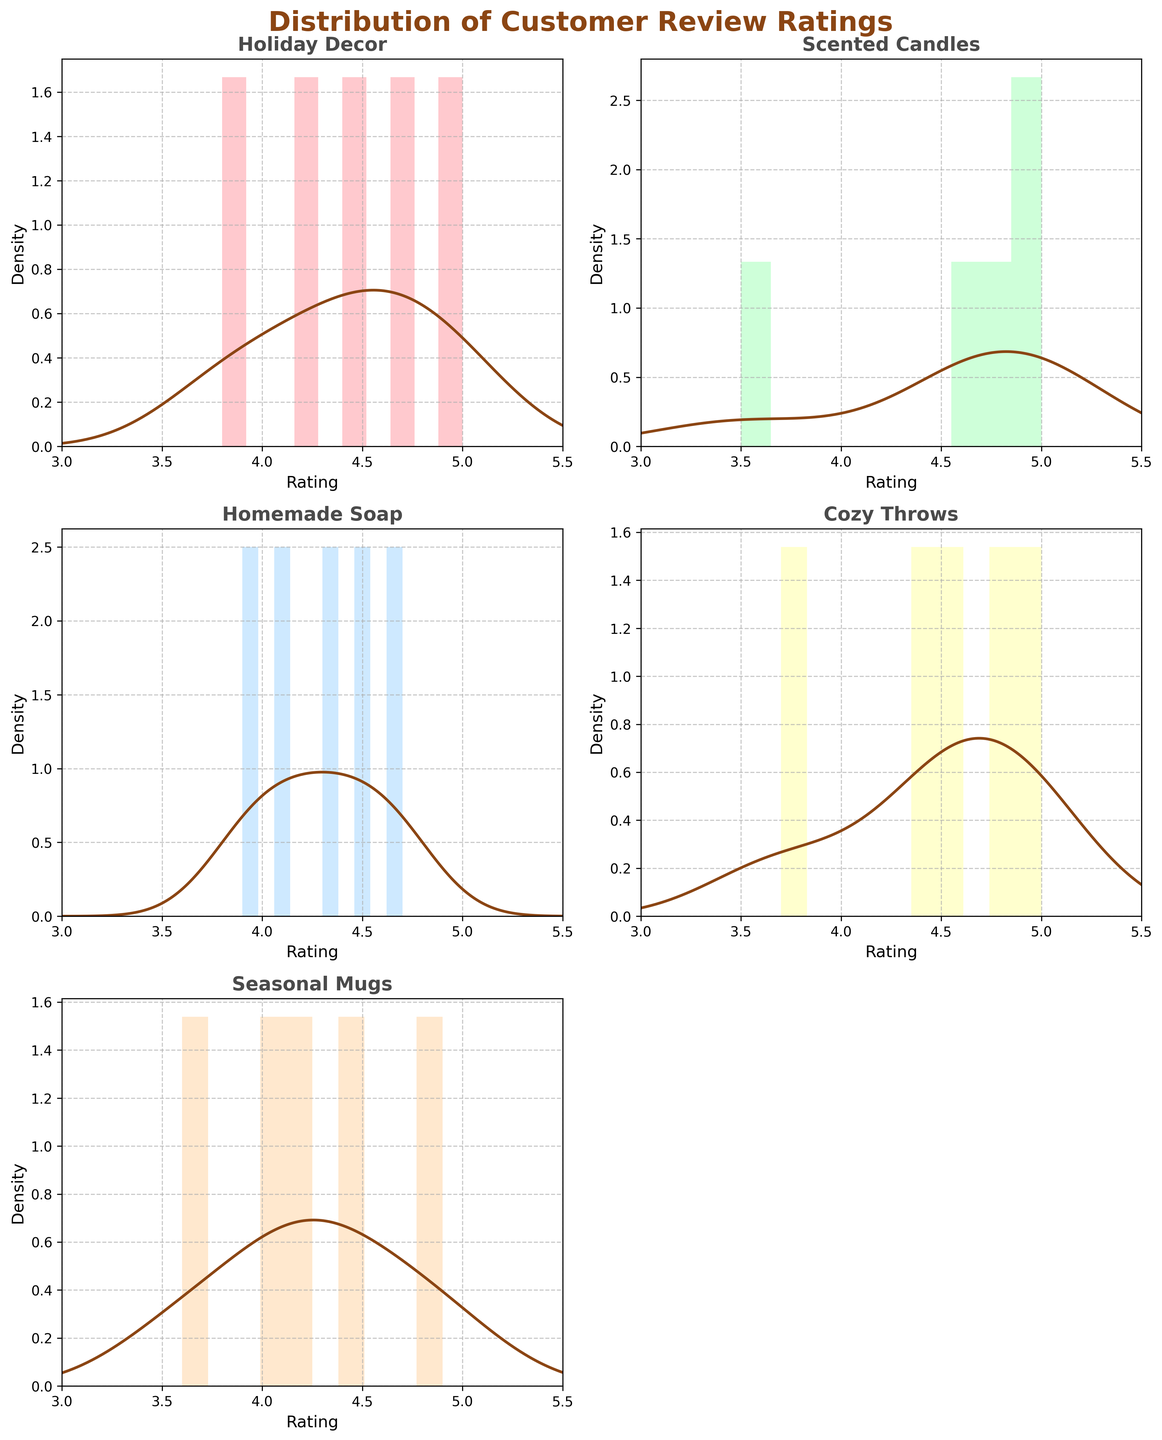What is the title of the figure? The title of the figure is usually found at the top. In this subplot format, the title states the overview of the data being represented.
Answer: Distribution of Customer Review Ratings How many subplots are present in the figure? The subplots are organized in a 3x2 layout but one subplot is empty. Counting the filled subplots reveals there are five, each representing a unique product line.
Answer: 5 Which product line shows the highest density at a rating of 5.0? By examining the peaks of the density curves at the rating value of 5.0, the subplot with the highest peak indicates the product line with the highest density for that rating.
Answer: Cozy Throws What is the range of customer ratings plotted on the X-axis? The X-axis, labeled 'Rating', shows a range over which customer ratings are plotted. By checking the limits set on the X-axis, one can deduce the range.
Answer: 3 to 5.5 Which product line has customer review ratings that are most spread out? The spread of customer review ratings can be visualized by the width of the density plot's distribution. A wider distribution means more spread-out ratings.
Answer: Seasonal Mugs Comparing Holiday Decor and Homemade Soap, which has a higher peak density value? By comparing the height of the density peaks between the two subplots, the one with the higher peak density value can be determined.
Answer: Holiday Decor On average, are the distributions for Scented Candles and Cozy Throws skewed more toward higher ratings (closer to 5)? Checking the shape of the density plots, if the majority of the area under the density curve is towards the higher end of the rating scale (closer to 5), it indicates positive skew towards higher ratings.
Answer: Yes Which subplot has the least variation in ratings received? A narrow spread of the density plot indicates less variation in ratings. Compare the width of all density plots to find the narrowest one.
Answer: Cozy Throws Is there any product line whose ratings lie primarily between 4.0 and 5.0? By examining the density plots, a product line whose density curve mostly lies between 4.0 and 5.0 can be identified.
Answer: Homemade Soap Which product lines have at least some ratings below 4.0? By observing where each density plot starts, it can be seen which product lines have ratings extending below 4.0.
Answer: Holiday Decor, Scented Candles, Cozy Throws, Seasonal Mugs 